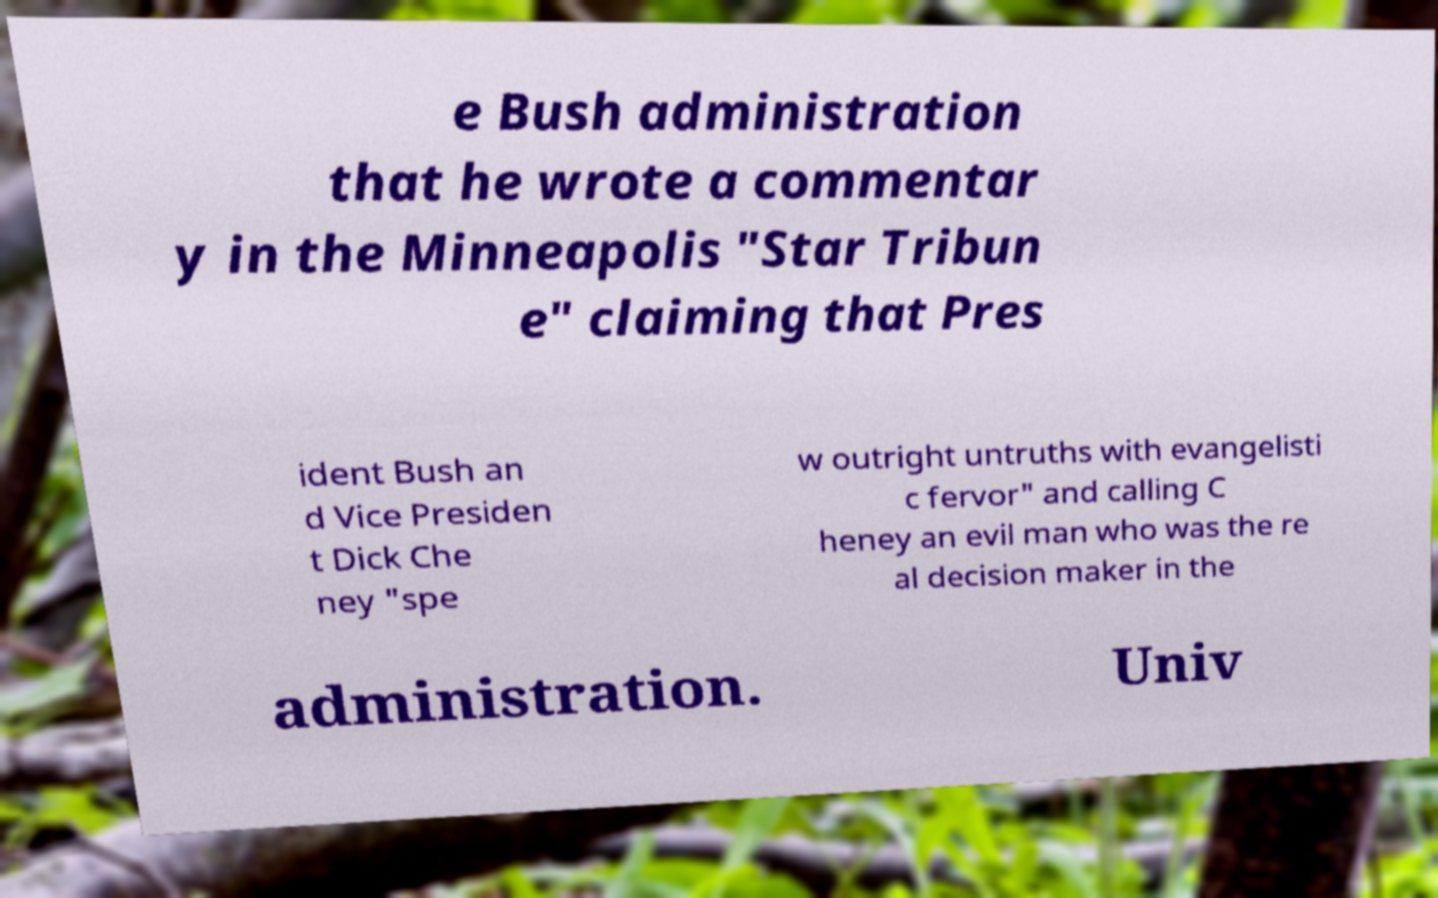For documentation purposes, I need the text within this image transcribed. Could you provide that? e Bush administration that he wrote a commentar y in the Minneapolis "Star Tribun e" claiming that Pres ident Bush an d Vice Presiden t Dick Che ney "spe w outright untruths with evangelisti c fervor" and calling C heney an evil man who was the re al decision maker in the administration. Univ 